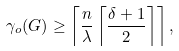<formula> <loc_0><loc_0><loc_500><loc_500>\gamma _ { o } ( G ) \geq \left \lceil \frac { n } { \lambda } \left \lceil \frac { \delta + 1 } { 2 } \right \rceil \right \rceil ,</formula> 